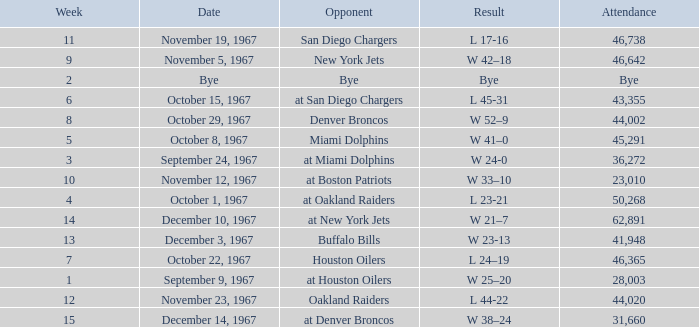Who was the opponent after week 9 with an attendance of 44,020? Oakland Raiders. 